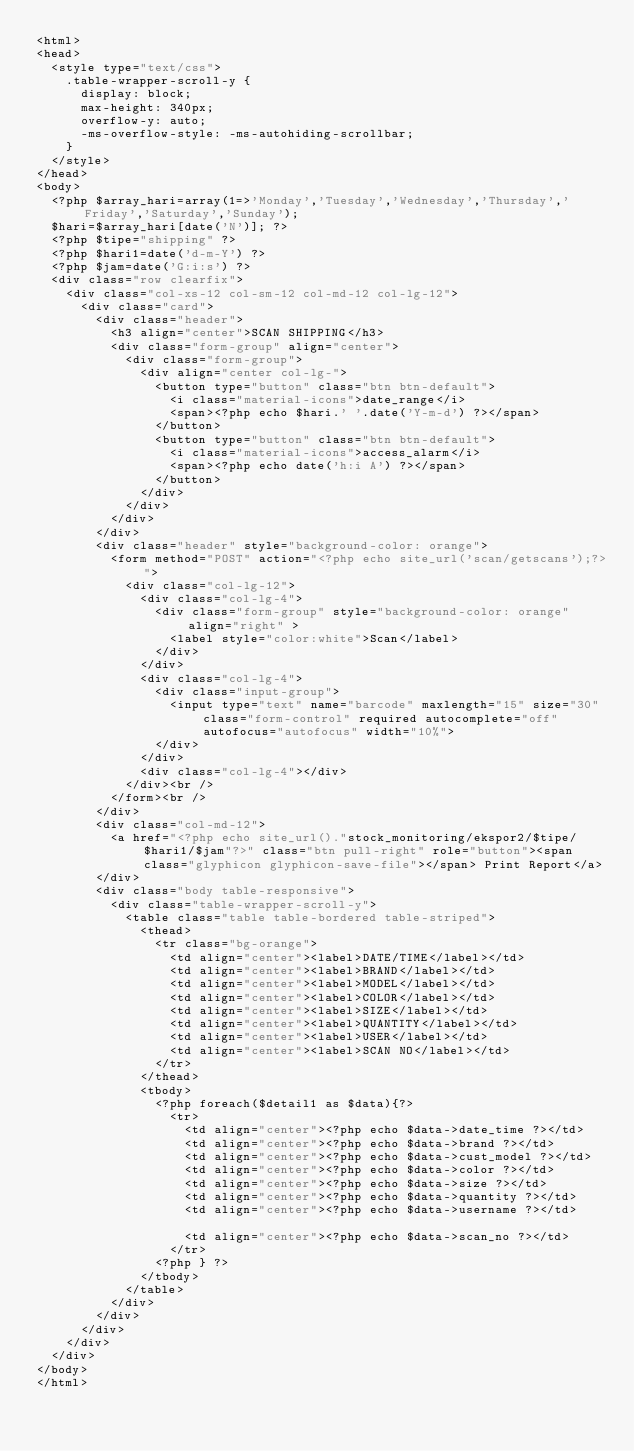<code> <loc_0><loc_0><loc_500><loc_500><_PHP_><html>
<head>
	<style type="text/css">
		.table-wrapper-scroll-y {
			display: block;
			max-height: 340px;
			overflow-y: auto;
			-ms-overflow-style: -ms-autohiding-scrollbar;
		}
	</style>
</head>
<body>
	<?php $array_hari=array(1=>'Monday','Tuesday','Wednesday','Thursday','Friday','Saturday','Sunday');
	$hari=$array_hari[date('N')]; ?>
	<?php $tipe="shipping" ?>
	<?php $hari1=date('d-m-Y') ?>
	<?php $jam=date('G:i:s') ?>
	<div class="row clearfix">
		<div class="col-xs-12 col-sm-12 col-md-12 col-lg-12">
			<div class="card">
				<div class="header">
					<h3 align="center">SCAN SHIPPING</h3>
					<div class="form-group" align="center">
						<div class="form-group">
							<div align="center col-lg-">
								<button type="button" class="btn btn-default">
									<i class="material-icons">date_range</i>
									<span><?php echo $hari.' '.date('Y-m-d') ?></span>
								</button>
								<button type="button" class="btn btn-default">
									<i class="material-icons">access_alarm</i>
									<span><?php echo date('h:i A') ?></span>
								</button>
							</div>   
						</div>
					</div>
				</div>
				<div class="header" style="background-color: orange">
					<form method="POST" action="<?php echo site_url('scan/getscans');?>">
						<div class="col-lg-12"> 
							<div class="col-lg-4">   
								<div class="form-group" style="background-color: orange" align="right" >
									<label style="color:white">Scan</label>
								</div>
							</div>
							<div class="col-lg-4">
								<div class="input-group">
									<input type="text" name="barcode" maxlength="15" size="30" class="form-control" required autocomplete="off" autofocus="autofocus" width="10%">
								</div>
							</div>
							<div class="col-lg-4"></div> 	  
						</div><br />   
					</form><br />
				</div>
				<div class="col-md-12">
					<a href="<?php echo site_url()."stock_monitoring/ekspor2/$tipe/$hari1/$jam"?>" class="btn pull-right" role="button"><span class="glyphicon glyphicon-save-file"></span> Print Report</a>
				</div>
				<div class="body table-responsive">
					<div class="table-wrapper-scroll-y">
						<table class="table table-bordered table-striped">
							<thead>
								<tr class="bg-orange">
									<td align="center"><label>DATE/TIME</label></td>
									<td align="center"><label>BRAND</label></td>
									<td align="center"><label>MODEL</label></td>
									<td align="center"><label>COLOR</label></td>
									<td align="center"><label>SIZE</label></td>
									<td align="center"><label>QUANTITY</label></td>
									<td align="center"><label>USER</label></td>
									<td align="center"><label>SCAN NO</label></td>
								</tr>
							</thead>
							<tbody>
								<?php foreach($detail1 as $data){?>
									<tr>
										<td align="center"><?php echo $data->date_time ?></td>
										<td align="center"><?php echo $data->brand ?></td>	
										<td align="center"><?php echo $data->cust_model ?></td>	
										<td align="center"><?php echo $data->color ?></td>	
										<td align="center"><?php echo $data->size ?></td>	
										<td align="center"><?php echo $data->quantity ?></td>
										<td align="center"><?php echo $data->username ?></td>				
										<td align="center"><?php echo $data->scan_no ?></td>		
									</tr>
								<?php }	?>
							</tbody>
						</table>
					</div>
				</div>
			</div>
		</div>
	</div>  		
</body>
</html>	</code> 